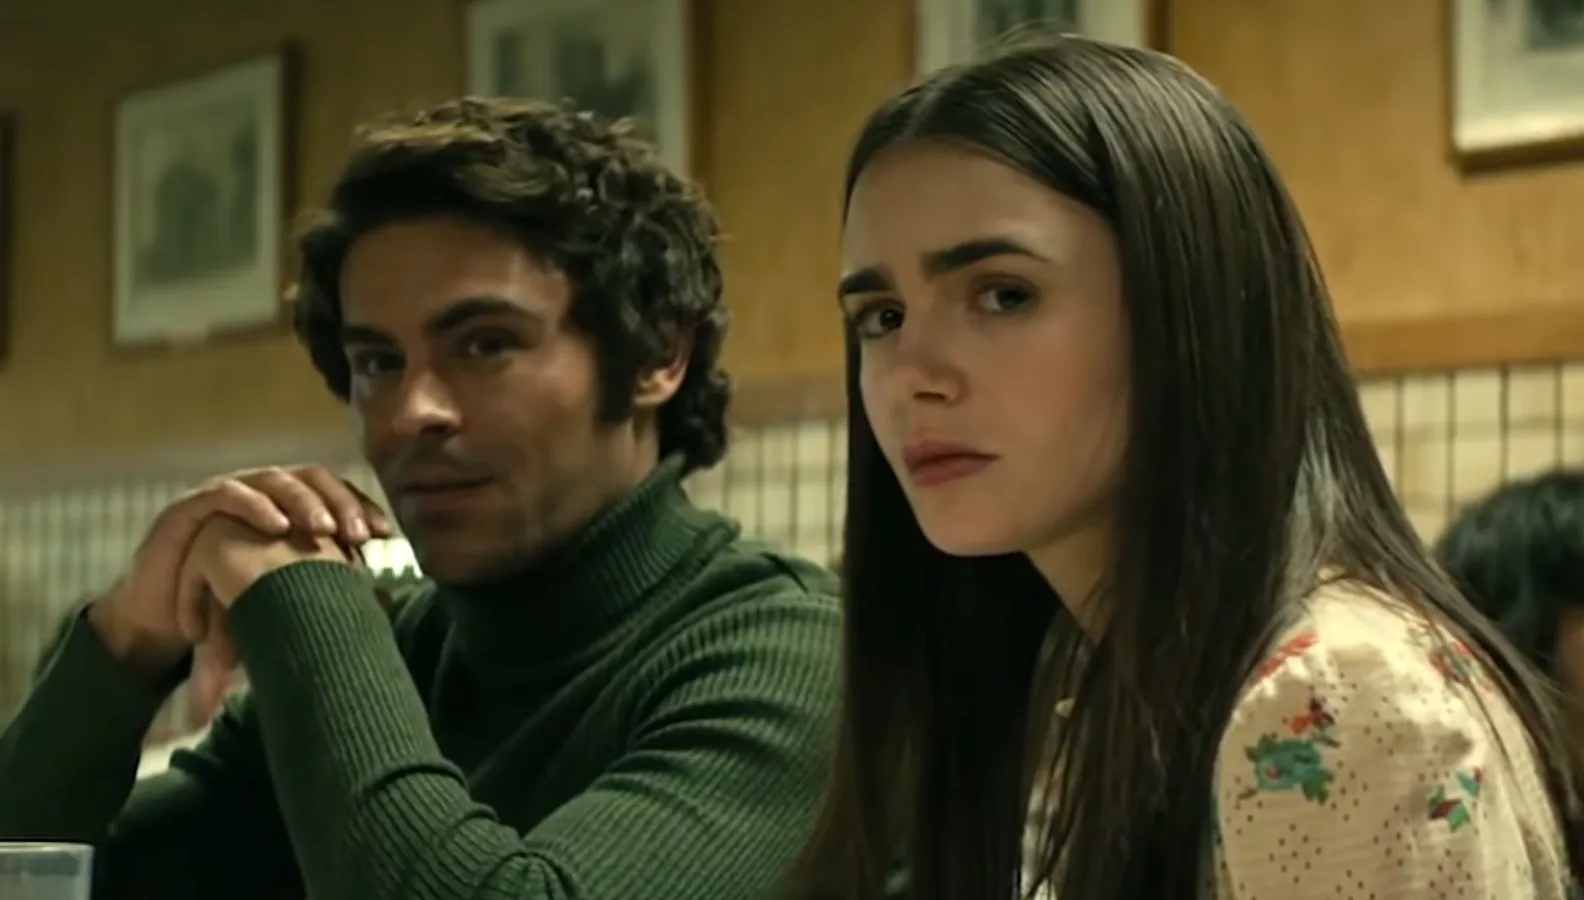If this scene were part of a mystery thriller, what clues or elements might be hidden in the background? In a mystery thriller context, the background holds subtle clues that might escape a casual observer. One of the framed pictures on the wall could depict a location linked to a recent crime, hinting at a connection to the characters’ investigation. The checkered pattern of the booth might have a stain or a mark indicating a past struggle or event of significance. A newspaper left on a nearby table could have a headline about a missing person or a cryptic crossword puzzle with key information. The varied patrons in the diner might also hold secrets, with one discreetly passing a note to another or casting furtive glances at the protagonists. These elements collectively create an atmosphere thick with potential leads and hidden dangers. 